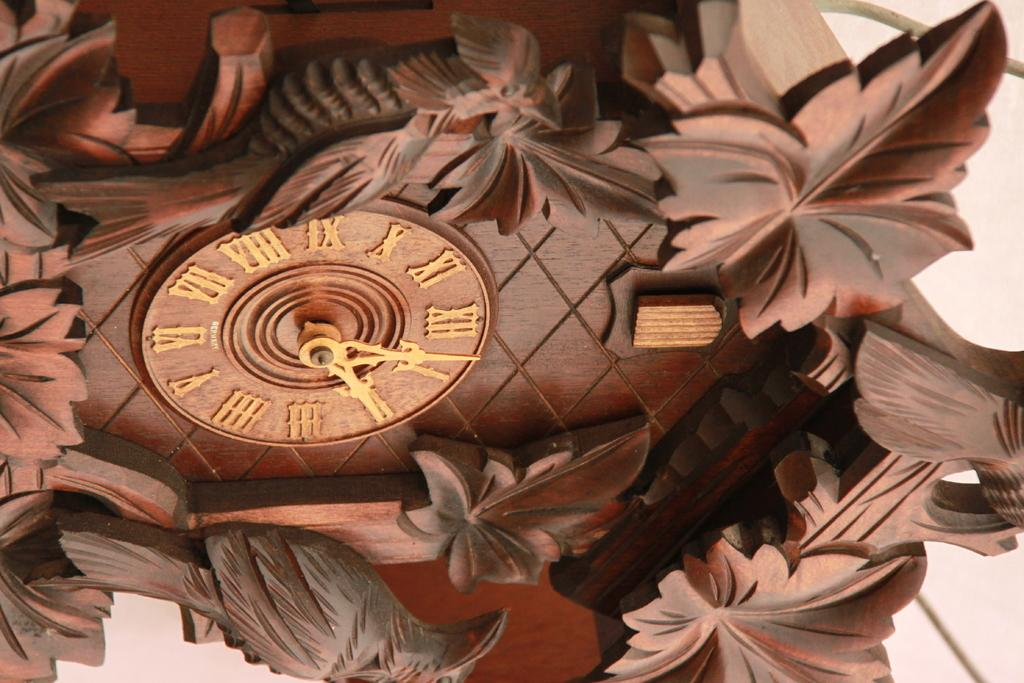<image>
Describe the image concisely. A wooden cuckoo clock features the numbers roman numerals, such XII and III. 